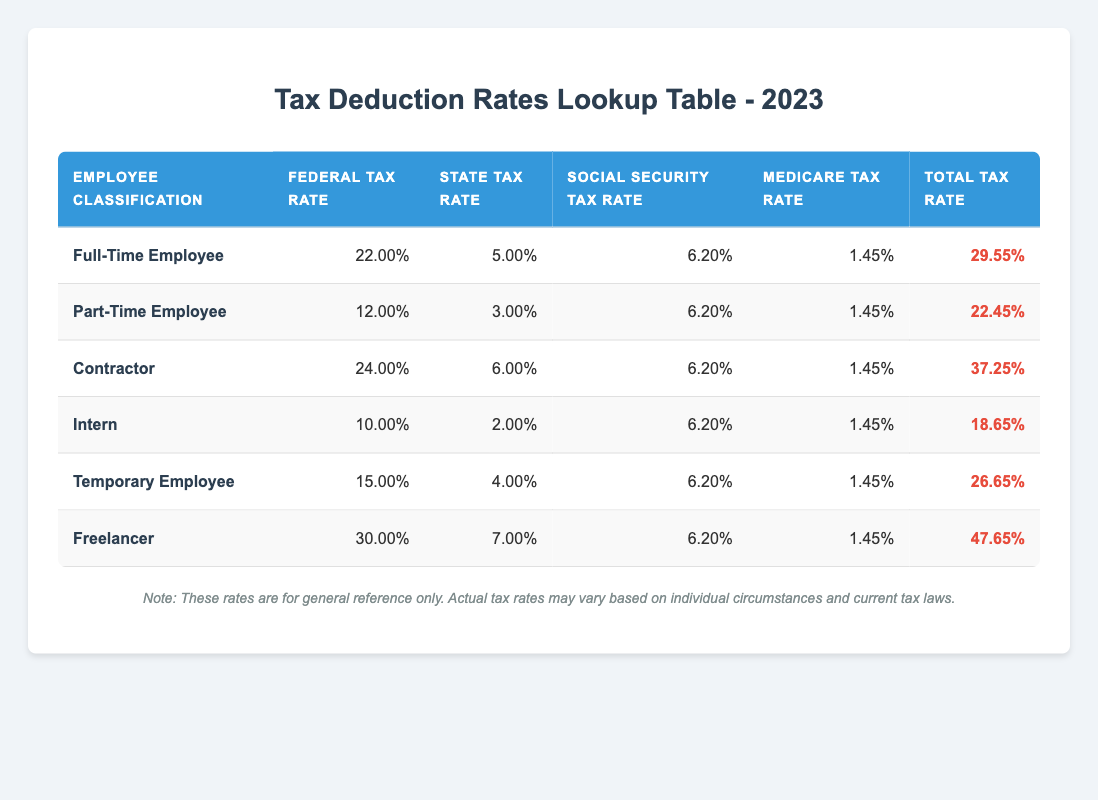What is the Federal Tax Rate for a Full-Time Employee? The table lists the Federal Tax Rate for a Full-Time Employee as 22.00%.
Answer: 22.00% What is the Total Tax Rate for an Intern? According to the table, the Total Tax Rate for an Intern is 18.65%.
Answer: 18.65% Is the State Tax Rate for Freelancers higher than that for Contractors? The State Tax Rate for Freelancers is 7.00%, while for Contractors it is 6.00%. Since 7.00% > 6.00%, the statement is true.
Answer: Yes What is the difference between the Total Tax Rates of Full-Time Employees and Part-Time Employees? The Total Tax Rate for Full-Time Employees is 29.55%, and for Part-Time Employees, it is 22.45%. The difference is calculated as 29.55% - 22.45% = 7.10%.
Answer: 7.10% What type of employee has the highest Total Tax Rate according to the table? The Freelancer classification has the highest Total Tax Rate at 47.65%, which is greater than all other classifications listed.
Answer: Freelancer What is the average Federal Tax Rate of Temporary Employees and Interns? The Federal Tax Rate for Temporary Employees is 15.00% and for Interns is 10.00%. To find the average, add them together: 15.00% + 10.00% = 25.00% then divide by 2 gives 25.00% / 2 = 12.50%.
Answer: 12.50% Are Social Security Tax Rates the same for all employee classifications? The Social Security Tax Rate is constant at 6.20% for all employee classifications listed in the table, confirming the statement is true.
Answer: Yes What is the Total Tax Rate for Part-Time Employees as a percentage? The Total Tax Rate for Part-Time Employees is explicitly stated in the table as 22.45%.
Answer: 22.45% Does the Total Tax Rate for Contractors exceed the combined Federal and State Tax Rates for Full-Time Employees? The Federal Tax Rate for Full-Time Employees is 22.00%, and the State Tax Rate is 5.00%. Their sum is 22.00% + 5.00% = 27.00%. The Total Tax Rate for Contractors is 37.25%, which exceeds 27.00%. Thus, the statement is true.
Answer: Yes 